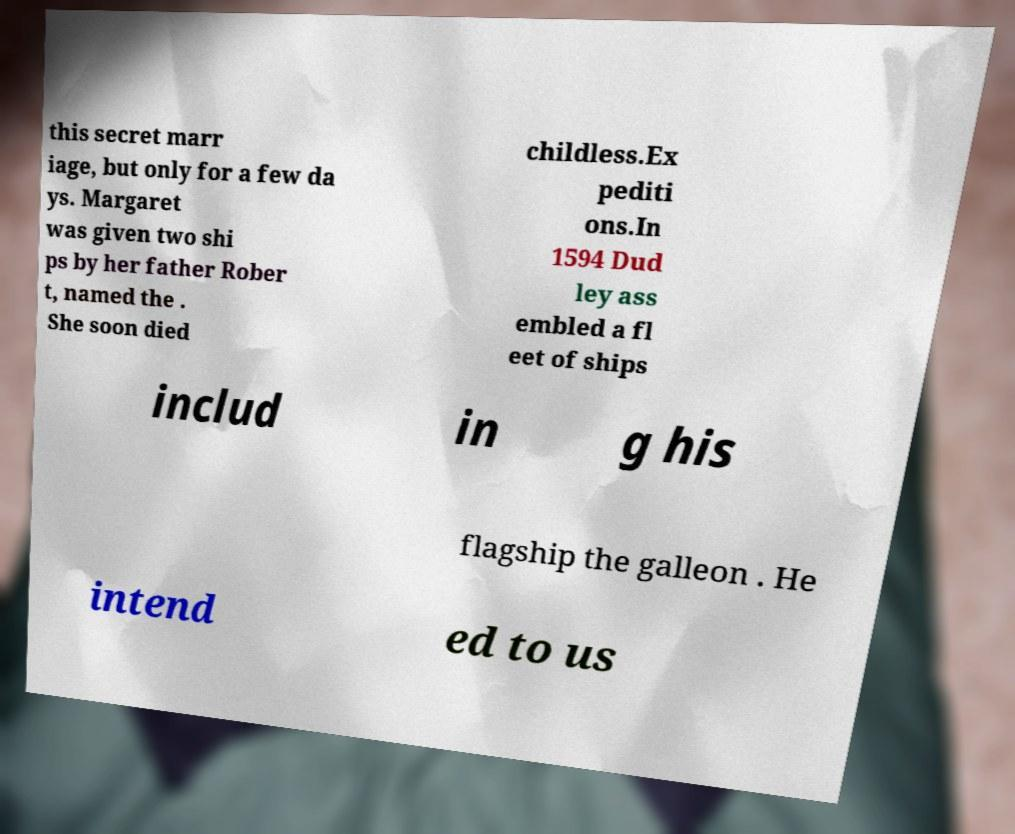For documentation purposes, I need the text within this image transcribed. Could you provide that? this secret marr iage, but only for a few da ys. Margaret was given two shi ps by her father Rober t, named the . She soon died childless.Ex pediti ons.In 1594 Dud ley ass embled a fl eet of ships includ in g his flagship the galleon . He intend ed to us 